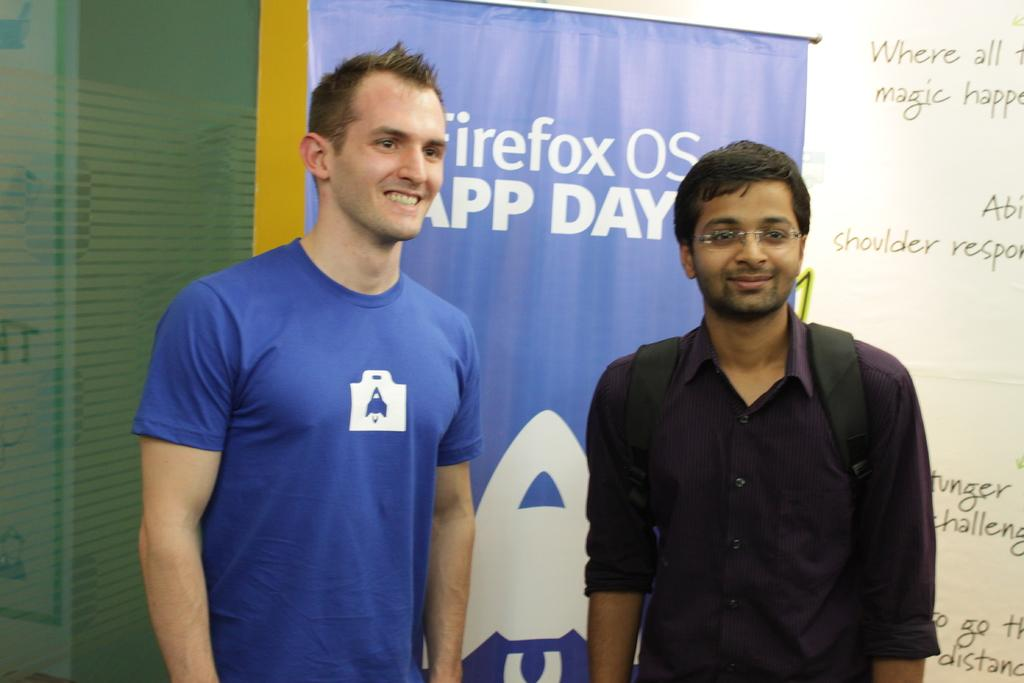<image>
Describe the image concisely. Two men standing in front of a banner which says "Day" on it. 